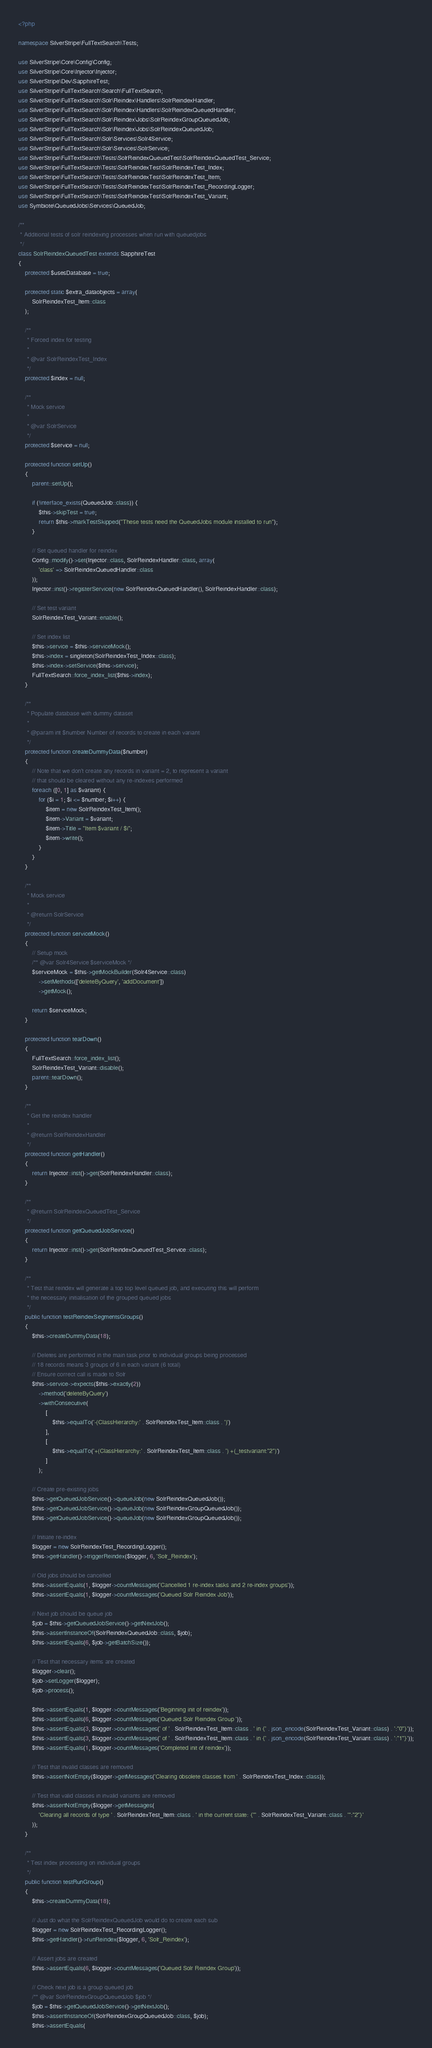Convert code to text. <code><loc_0><loc_0><loc_500><loc_500><_PHP_><?php

namespace SilverStripe\FullTextSearch\Tests;

use SilverStripe\Core\Config\Config;
use SilverStripe\Core\Injector\Injector;
use SilverStripe\Dev\SapphireTest;
use SilverStripe\FullTextSearch\Search\FullTextSearch;
use SilverStripe\FullTextSearch\Solr\Reindex\Handlers\SolrReindexHandler;
use SilverStripe\FullTextSearch\Solr\Reindex\Handlers\SolrReindexQueuedHandler;
use SilverStripe\FullTextSearch\Solr\Reindex\Jobs\SolrReindexGroupQueuedJob;
use SilverStripe\FullTextSearch\Solr\Reindex\Jobs\SolrReindexQueuedJob;
use SilverStripe\FullTextSearch\Solr\Services\Solr4Service;
use SilverStripe\FullTextSearch\Solr\Services\SolrService;
use SilverStripe\FullTextSearch\Tests\SolrReindexQueuedTest\SolrReindexQueuedTest_Service;
use SilverStripe\FullTextSearch\Tests\SolrReindexTest\SolrReindexTest_Index;
use SilverStripe\FullTextSearch\Tests\SolrReindexTest\SolrReindexTest_Item;
use SilverStripe\FullTextSearch\Tests\SolrReindexTest\SolrReindexTest_RecordingLogger;
use SilverStripe\FullTextSearch\Tests\SolrReindexTest\SolrReindexTest_Variant;
use Symbiote\QueuedJobs\Services\QueuedJob;

/**
 * Additional tests of solr reindexing processes when run with queuedjobs
 */
class SolrReindexQueuedTest extends SapphireTest
{
    protected $usesDatabase = true;

    protected static $extra_dataobjects = array(
        SolrReindexTest_Item::class
    );

    /**
     * Forced index for testing
     *
     * @var SolrReindexTest_Index
     */
    protected $index = null;

    /**
     * Mock service
     *
     * @var SolrService
     */
    protected $service = null;

    protected function setUp()
    {
        parent::setUp();

        if (!interface_exists(QueuedJob::class)) {
            $this->skipTest = true;
            return $this->markTestSkipped("These tests need the QueuedJobs module installed to run");
        }

        // Set queued handler for reindex
        Config::modify()->set(Injector::class, SolrReindexHandler::class, array(
            'class' => SolrReindexQueuedHandler::class
        ));
        Injector::inst()->registerService(new SolrReindexQueuedHandler(), SolrReindexHandler::class);

        // Set test variant
        SolrReindexTest_Variant::enable();

        // Set index list
        $this->service = $this->serviceMock();
        $this->index = singleton(SolrReindexTest_Index::class);
        $this->index->setService($this->service);
        FullTextSearch::force_index_list($this->index);
    }

    /**
     * Populate database with dummy dataset
     *
     * @param int $number Number of records to create in each variant
     */
    protected function createDummyData($number)
    {
        // Note that we don't create any records in variant = 2, to represent a variant
        // that should be cleared without any re-indexes performed
        foreach ([0, 1] as $variant) {
            for ($i = 1; $i <= $number; $i++) {
                $item = new SolrReindexTest_Item();
                $item->Variant = $variant;
                $item->Title = "Item $variant / $i";
                $item->write();
            }
        }
    }

    /**
     * Mock service
     *
     * @return SolrService
     */
    protected function serviceMock()
    {
        // Setup mock
        /** @var Solr4Service $serviceMock */
        $serviceMock = $this->getMockBuilder(Solr4Service::class)
            ->setMethods(['deleteByQuery', 'addDocument'])
            ->getMock();

        return $serviceMock;
    }

    protected function tearDown()
    {
        FullTextSearch::force_index_list();
        SolrReindexTest_Variant::disable();
        parent::tearDown();
    }

    /**
     * Get the reindex handler
     *
     * @return SolrReindexHandler
     */
    protected function getHandler()
    {
        return Injector::inst()->get(SolrReindexHandler::class);
    }

    /**
     * @return SolrReindexQueuedTest_Service
     */
    protected function getQueuedJobService()
    {
        return Injector::inst()->get(SolrReindexQueuedTest_Service::class);
    }

    /**
     * Test that reindex will generate a top top level queued job, and executing this will perform
     * the necessary initialisation of the grouped queued jobs
     */
    public function testReindexSegmentsGroups()
    {
        $this->createDummyData(18);

        // Deletes are performed in the main task prior to individual groups being processed
        // 18 records means 3 groups of 6 in each variant (6 total)
        // Ensure correct call is made to Solr
        $this->service->expects($this->exactly(2))
            ->method('deleteByQuery')
            ->withConsecutive(
                [
                    $this->equalTo('-(ClassHierarchy:' . SolrReindexTest_Item::class . ')')
                ],
                [
                    $this->equalTo('+(ClassHierarchy:' . SolrReindexTest_Item::class . ') +(_testvariant:"2")')
                ]
            );

        // Create pre-existing jobs
        $this->getQueuedJobService()->queueJob(new SolrReindexQueuedJob());
        $this->getQueuedJobService()->queueJob(new SolrReindexGroupQueuedJob());
        $this->getQueuedJobService()->queueJob(new SolrReindexGroupQueuedJob());

        // Initiate re-index
        $logger = new SolrReindexTest_RecordingLogger();
        $this->getHandler()->triggerReindex($logger, 6, 'Solr_Reindex');

        // Old jobs should be cancelled
        $this->assertEquals(1, $logger->countMessages('Cancelled 1 re-index tasks and 2 re-index groups'));
        $this->assertEquals(1, $logger->countMessages('Queued Solr Reindex Job'));

        // Next job should be queue job
        $job = $this->getQueuedJobService()->getNextJob();
        $this->assertInstanceOf(SolrReindexQueuedJob::class, $job);
        $this->assertEquals(6, $job->getBatchSize());

        // Test that necessary items are created
        $logger->clear();
        $job->setLogger($logger);
        $job->process();

        $this->assertEquals(1, $logger->countMessages('Beginning init of reindex'));
        $this->assertEquals(6, $logger->countMessages('Queued Solr Reindex Group '));
        $this->assertEquals(3, $logger->countMessages(' of ' . SolrReindexTest_Item::class . ' in {' . json_encode(SolrReindexTest_Variant::class) . ':"0"}'));
        $this->assertEquals(3, $logger->countMessages(' of ' . SolrReindexTest_Item::class . ' in {' . json_encode(SolrReindexTest_Variant::class) . ':"1"}'));
        $this->assertEquals(1, $logger->countMessages('Completed init of reindex'));

        // Test that invalid classes are removed
        $this->assertNotEmpty($logger->getMessages('Clearing obsolete classes from ' . SolrReindexTest_Index::class));

        // Test that valid classes in invalid variants are removed
        $this->assertNotEmpty($logger->getMessages(
            'Clearing all records of type ' . SolrReindexTest_Item::class . ' in the current state: {"' . SolrReindexTest_Variant::class . '":"2"}'
        ));
    }

    /**
     * Test index processing on individual groups
     */
    public function testRunGroup()
    {
        $this->createDummyData(18);

        // Just do what the SolrReindexQueuedJob would do to create each sub
        $logger = new SolrReindexTest_RecordingLogger();
        $this->getHandler()->runReindex($logger, 6, 'Solr_Reindex');

        // Assert jobs are created
        $this->assertEquals(6, $logger->countMessages('Queued Solr Reindex Group'));

        // Check next job is a group queued job
        /** @var SolrReindexGroupQueuedJob $job */
        $job = $this->getQueuedJobService()->getNextJob();
        $this->assertInstanceOf(SolrReindexGroupQueuedJob::class, $job);
        $this->assertEquals(</code> 